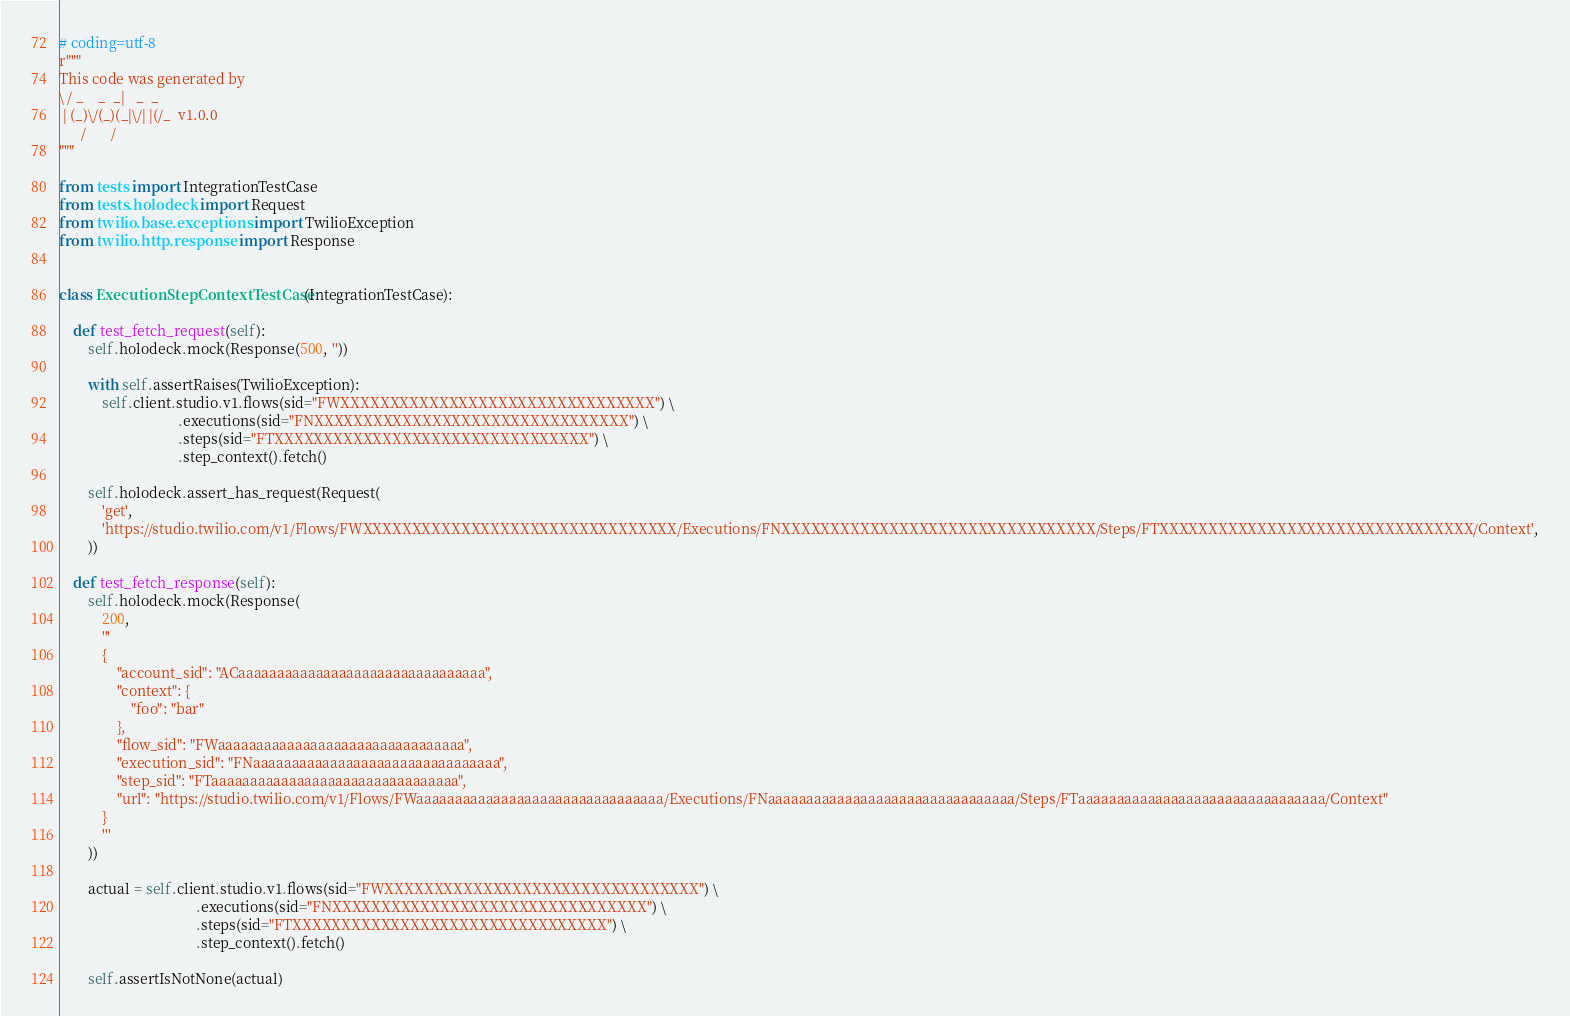<code> <loc_0><loc_0><loc_500><loc_500><_Python_># coding=utf-8
r"""
This code was generated by
\ / _    _  _|   _  _
 | (_)\/(_)(_|\/| |(/_  v1.0.0
      /       /
"""

from tests import IntegrationTestCase
from tests.holodeck import Request
from twilio.base.exceptions import TwilioException
from twilio.http.response import Response


class ExecutionStepContextTestCase(IntegrationTestCase):

    def test_fetch_request(self):
        self.holodeck.mock(Response(500, ''))

        with self.assertRaises(TwilioException):
            self.client.studio.v1.flows(sid="FWXXXXXXXXXXXXXXXXXXXXXXXXXXXXXXXX") \
                                 .executions(sid="FNXXXXXXXXXXXXXXXXXXXXXXXXXXXXXXXX") \
                                 .steps(sid="FTXXXXXXXXXXXXXXXXXXXXXXXXXXXXXXXX") \
                                 .step_context().fetch()

        self.holodeck.assert_has_request(Request(
            'get',
            'https://studio.twilio.com/v1/Flows/FWXXXXXXXXXXXXXXXXXXXXXXXXXXXXXXXX/Executions/FNXXXXXXXXXXXXXXXXXXXXXXXXXXXXXXXX/Steps/FTXXXXXXXXXXXXXXXXXXXXXXXXXXXXXXXX/Context',
        ))

    def test_fetch_response(self):
        self.holodeck.mock(Response(
            200,
            '''
            {
                "account_sid": "ACaaaaaaaaaaaaaaaaaaaaaaaaaaaaaaaa",
                "context": {
                    "foo": "bar"
                },
                "flow_sid": "FWaaaaaaaaaaaaaaaaaaaaaaaaaaaaaaaa",
                "execution_sid": "FNaaaaaaaaaaaaaaaaaaaaaaaaaaaaaaaa",
                "step_sid": "FTaaaaaaaaaaaaaaaaaaaaaaaaaaaaaaaa",
                "url": "https://studio.twilio.com/v1/Flows/FWaaaaaaaaaaaaaaaaaaaaaaaaaaaaaaaa/Executions/FNaaaaaaaaaaaaaaaaaaaaaaaaaaaaaaaa/Steps/FTaaaaaaaaaaaaaaaaaaaaaaaaaaaaaaaa/Context"
            }
            '''
        ))

        actual = self.client.studio.v1.flows(sid="FWXXXXXXXXXXXXXXXXXXXXXXXXXXXXXXXX") \
                                      .executions(sid="FNXXXXXXXXXXXXXXXXXXXXXXXXXXXXXXXX") \
                                      .steps(sid="FTXXXXXXXXXXXXXXXXXXXXXXXXXXXXXXXX") \
                                      .step_context().fetch()

        self.assertIsNotNone(actual)
</code> 